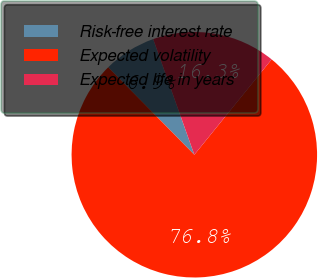Convert chart. <chart><loc_0><loc_0><loc_500><loc_500><pie_chart><fcel>Risk-free interest rate<fcel>Expected volatility<fcel>Expected life in years<nl><fcel>6.94%<fcel>76.78%<fcel>16.28%<nl></chart> 